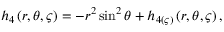<formula> <loc_0><loc_0><loc_500><loc_500>h _ { 4 } \left ( r , \theta , \varsigma \right ) = - r ^ { 2 } \sin ^ { 2 } \theta + h _ { 4 ( \varsigma ) } \left ( r , \theta , \varsigma \right ) ,</formula> 